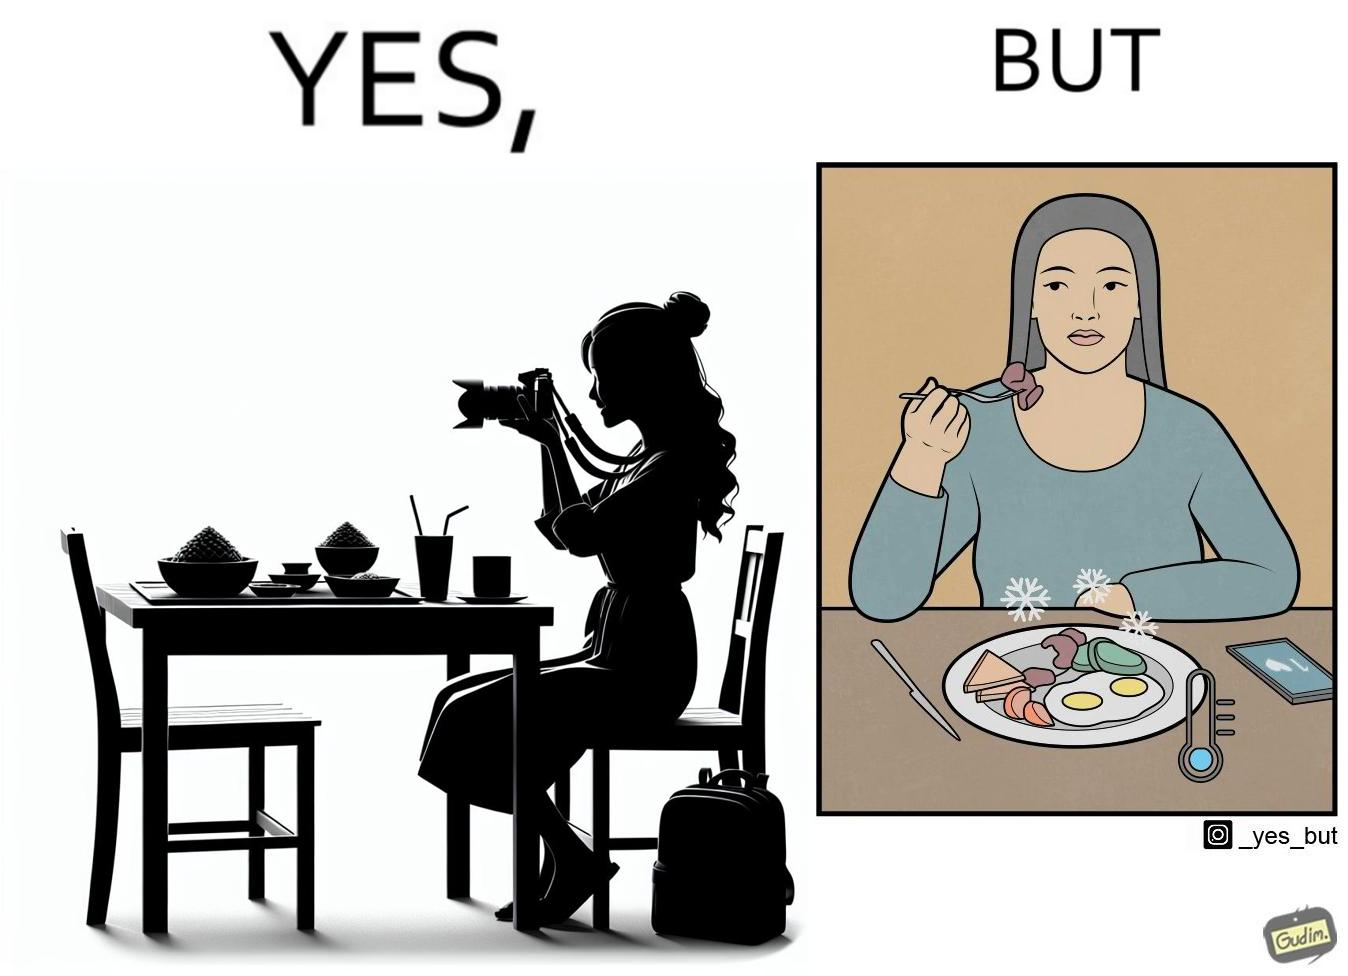Would you classify this image as satirical? Yes, this image is satirical. 